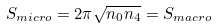Convert formula to latex. <formula><loc_0><loc_0><loc_500><loc_500>S _ { m i c r o } = 2 \pi \sqrt { n _ { 0 } n _ { 4 } } = S _ { m a c r o }</formula> 